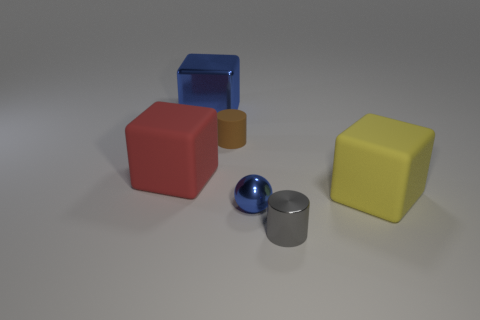Subtract all matte blocks. How many blocks are left? 1 Add 3 big blue things. How many objects exist? 9 Subtract all spheres. How many objects are left? 5 Subtract all large cubes. Subtract all tiny brown things. How many objects are left? 2 Add 1 blue spheres. How many blue spheres are left? 2 Add 4 big cubes. How many big cubes exist? 7 Subtract 1 yellow blocks. How many objects are left? 5 